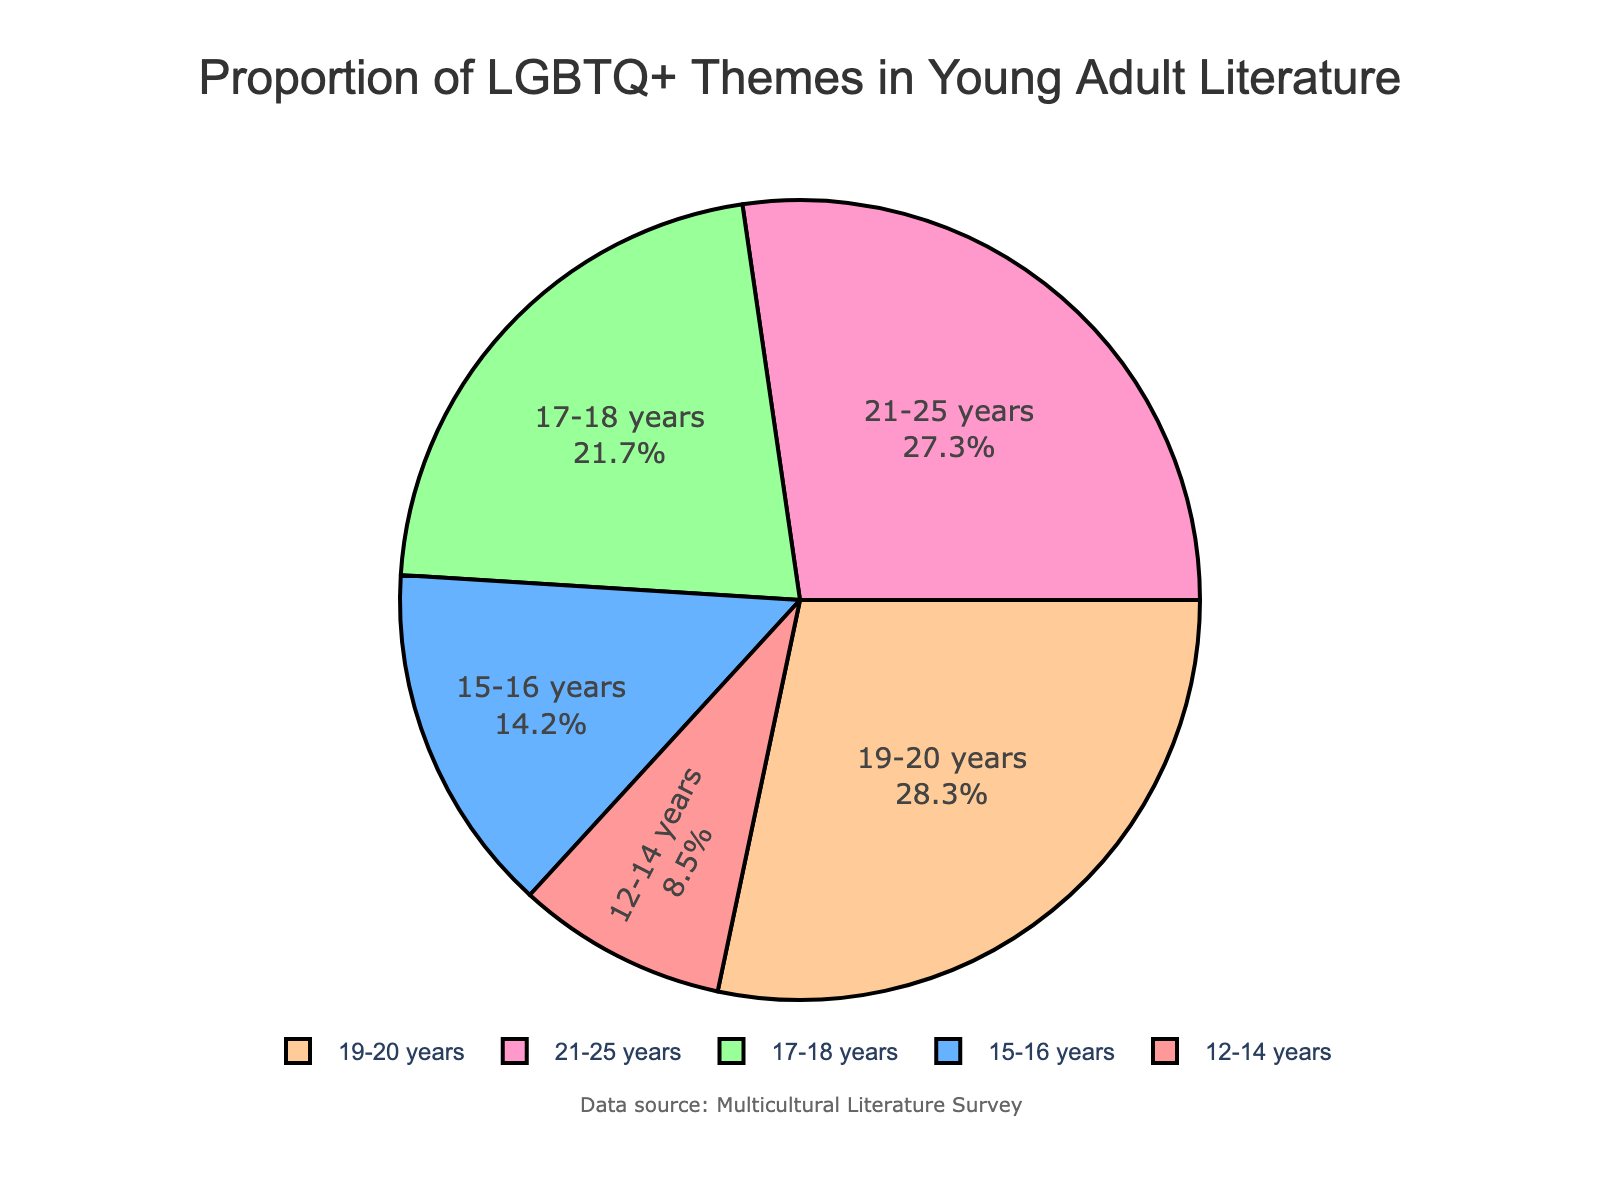What age group has the highest proportion of LGBTQ+ themes in young adult literature? By examining the pie chart, we can see the percentage values associated with each age group. The age group with the value 28.3 is the highest.
Answer: 19-20 years What age group has the lowest proportion of LGBTQ+ themes in young adult literature? By examining the pie chart, we can see the percentage values associated with each age group. The age group with the value 8.5 is the lowest.
Answer: 12-14 years What's the difference in the proportion of LGBTQ+ themes between the 17-18 years group and the 12-14 years group? The percentages for the age groups 17-18 years and 12-14 years are 21.7 and 8.5, respectively. The difference is calculated as 21.7 - 8.5.
Answer: 13.2 How does the proportion of LGBTQ+ themes in the 21-25 years group compare to the 19-20 years group? The percentage for the 21-25 years group is 27.3, and for the 19-20 years group, it is 28.3. So, 27.3 is slightly less than 28.3.
Answer: Less What is the cumulative percentage of LGBTQ+ themes in the literature for the age groups 15-16 years and 17-18 years? The percentages for the age groups 15-16 years and 17-18 years are 14.2 and 21.7, respectively. Adding these gives 14.2 + 21.7.
Answer: 35.9 Which age group occupies the pinkish-red section of the pie chart? By looking at the colors assigned to each segment in the pie chart, the pinkish-red section corresponds to the age group with the lowest value, 12-14 years.
Answer: 12-14 years What is the total percentage of LGBTQ+ themes for the 17-18 years and 19-20 years combined? The percentages for the age groups 17-18 years and 19-20 years are 21.7 and 28.3, respectively. Adding these gives 21.7 + 28.3.
Answer: 50 How does the visual size of the 15-16 years group's segment compare to the 12-14 years group's segment in the pie chart? By visually inspecting the pie chart, the segment representing 15-16 years is larger than the segment representing 12-14 years due to the higher percentage value of 14.2 compared to 8.5.
Answer: Larger 